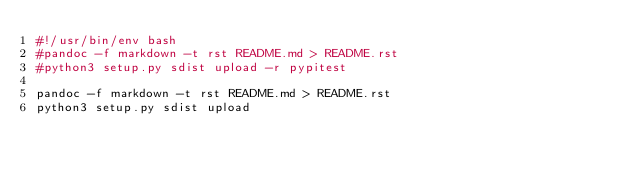Convert code to text. <code><loc_0><loc_0><loc_500><loc_500><_Bash_>#!/usr/bin/env bash
#pandoc -f markdown -t rst README.md > README.rst
#python3 setup.py sdist upload -r pypitest

pandoc -f markdown -t rst README.md > README.rst
python3 setup.py sdist upload
</code> 